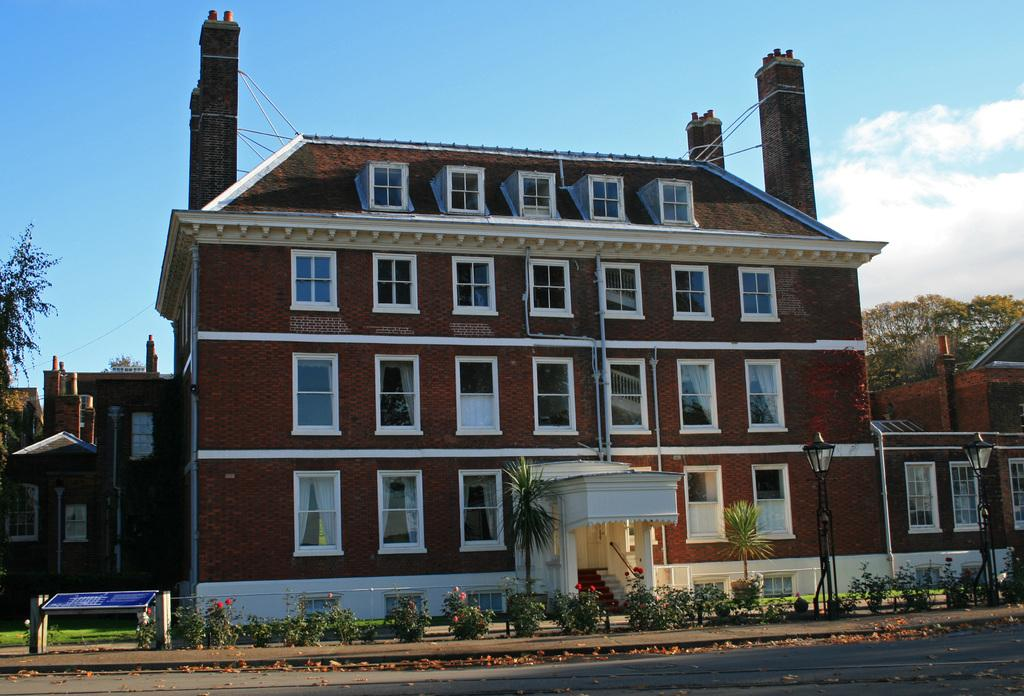What types of vegetation are present at the bottom of the image? There are plants and trees at the bottom of the image. What other objects can be seen at the bottom of the image? There are poles at the bottom of the image. What can be seen in the background of the image? There are trees and a building in the background of the image. What is visible at the top of the image? The sky is cloudy and visible at the top of the image. Reasoning: Let' Let's think step by step in order to produce the conversation. We start by identifying the main subjects and objects in the image based on the provided facts. We then formulate questions that focus on the location and characteristics of these subjects and objects, ensuring that each question can be answered definitively with the information given. We avoid yes/no questions and ensure that the language is simple and clear. Absurd Question/Answer: Can you tell me how many teeth the rat has in the image? There is no rat present in the image, so it is not possible to determine the number of teeth it might have. What type of crime is being committed in the image? There is no crime depicted in the image; it features plants, trees, poles, a building, and a cloudy sky. How many teeth does the rat have in the image? There is no rat present in the image, so it is not possible to determine the number of teeth it might have. 